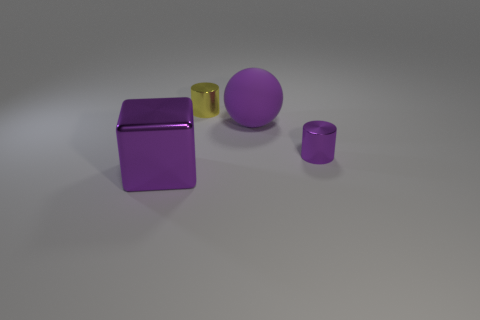What number of objects are big purple matte balls or purple objects that are behind the tiny purple object?
Your answer should be very brief. 1. Is there another big matte object that has the same color as the matte thing?
Provide a succinct answer. No. How many blue things are either metallic cylinders or cubes?
Your answer should be very brief. 0. How many other things are the same size as the purple rubber sphere?
Provide a short and direct response. 1. What number of large things are either purple shiny cylinders or purple objects?
Your response must be concise. 2. There is a purple cube; is it the same size as the shiny thing that is on the right side of the small yellow cylinder?
Offer a terse response. No. How many other things are there of the same shape as the big purple metallic thing?
Ensure brevity in your answer.  0. The large object that is the same material as the small purple cylinder is what shape?
Your response must be concise. Cube. Are any yellow objects visible?
Offer a very short reply. Yes. Is the number of large purple matte objects that are in front of the purple block less than the number of large spheres that are behind the tiny yellow shiny cylinder?
Provide a succinct answer. No. 